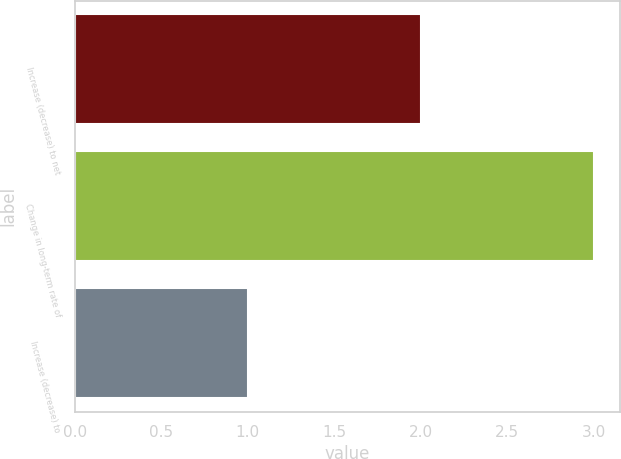Convert chart to OTSL. <chart><loc_0><loc_0><loc_500><loc_500><bar_chart><fcel>Increase (decrease) to net<fcel>Change in long-term rate of<fcel>Increase (decrease) to<nl><fcel>2<fcel>3<fcel>1<nl></chart> 